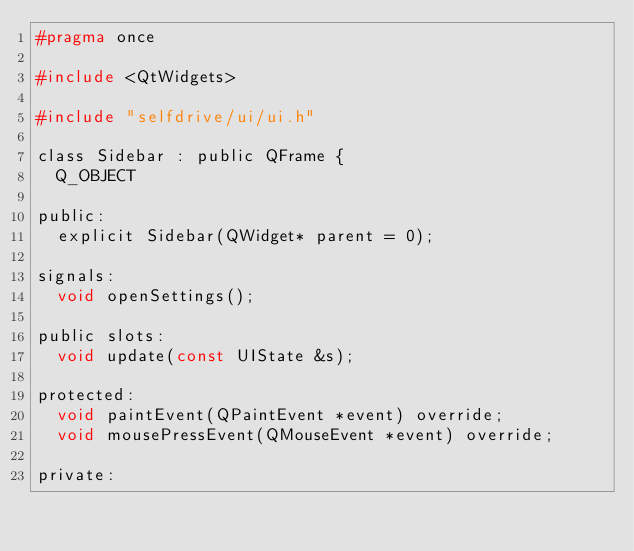<code> <loc_0><loc_0><loc_500><loc_500><_C_>#pragma once

#include <QtWidgets>

#include "selfdrive/ui/ui.h"

class Sidebar : public QFrame {
  Q_OBJECT

public:
  explicit Sidebar(QWidget* parent = 0);

signals:
  void openSettings();

public slots:
  void update(const UIState &s);

protected:
  void paintEvent(QPaintEvent *event) override;
  void mousePressEvent(QMouseEvent *event) override;

private:</code> 